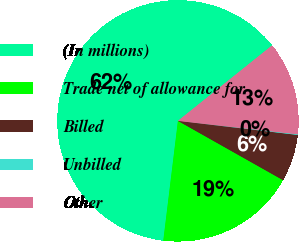Convert chart to OTSL. <chart><loc_0><loc_0><loc_500><loc_500><pie_chart><fcel>(In millions)<fcel>Trade net of allowance for<fcel>Billed<fcel>Unbilled<fcel>Other<nl><fcel>62.3%<fcel>18.76%<fcel>6.31%<fcel>0.09%<fcel>12.53%<nl></chart> 